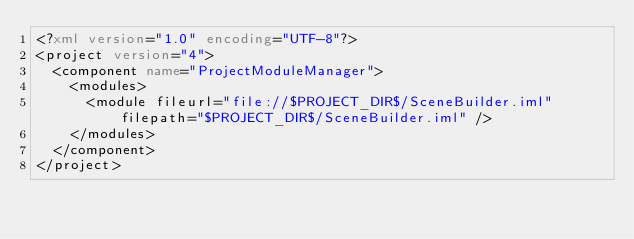Convert code to text. <code><loc_0><loc_0><loc_500><loc_500><_XML_><?xml version="1.0" encoding="UTF-8"?>
<project version="4">
  <component name="ProjectModuleManager">
    <modules>
      <module fileurl="file://$PROJECT_DIR$/SceneBuilder.iml" filepath="$PROJECT_DIR$/SceneBuilder.iml" />
    </modules>
  </component>
</project></code> 